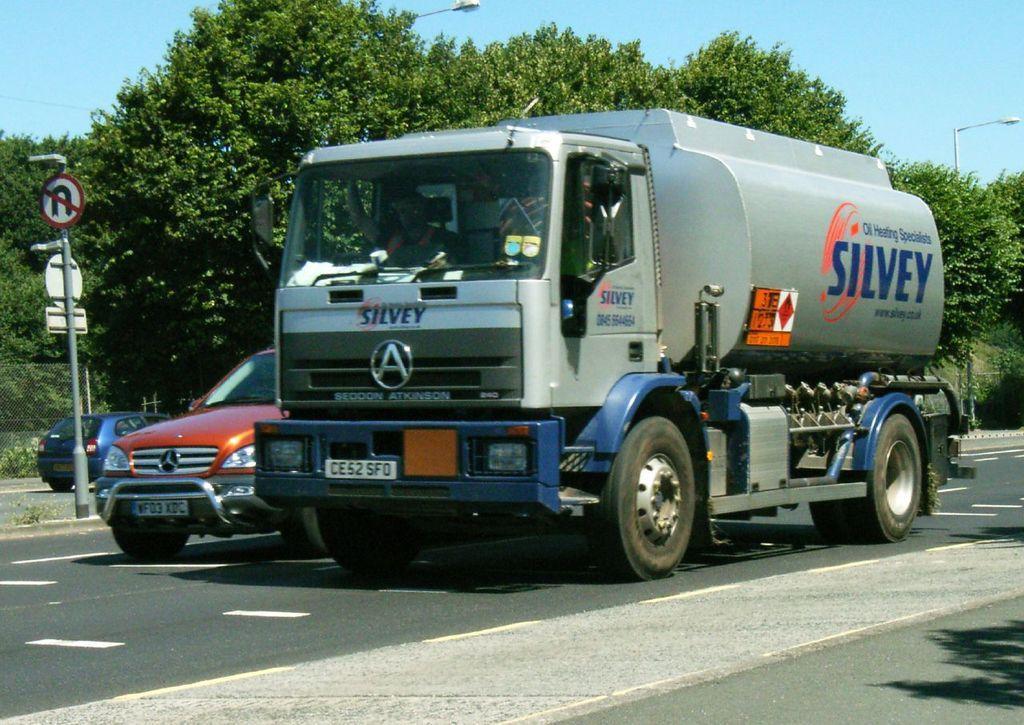Describe this image in one or two sentences. In the image we can see on the road there are vehicles which are parked and there is a truck and a car and on footpath there is a sign board pole and behind there are lot of trees and there are street light poles on the road. 